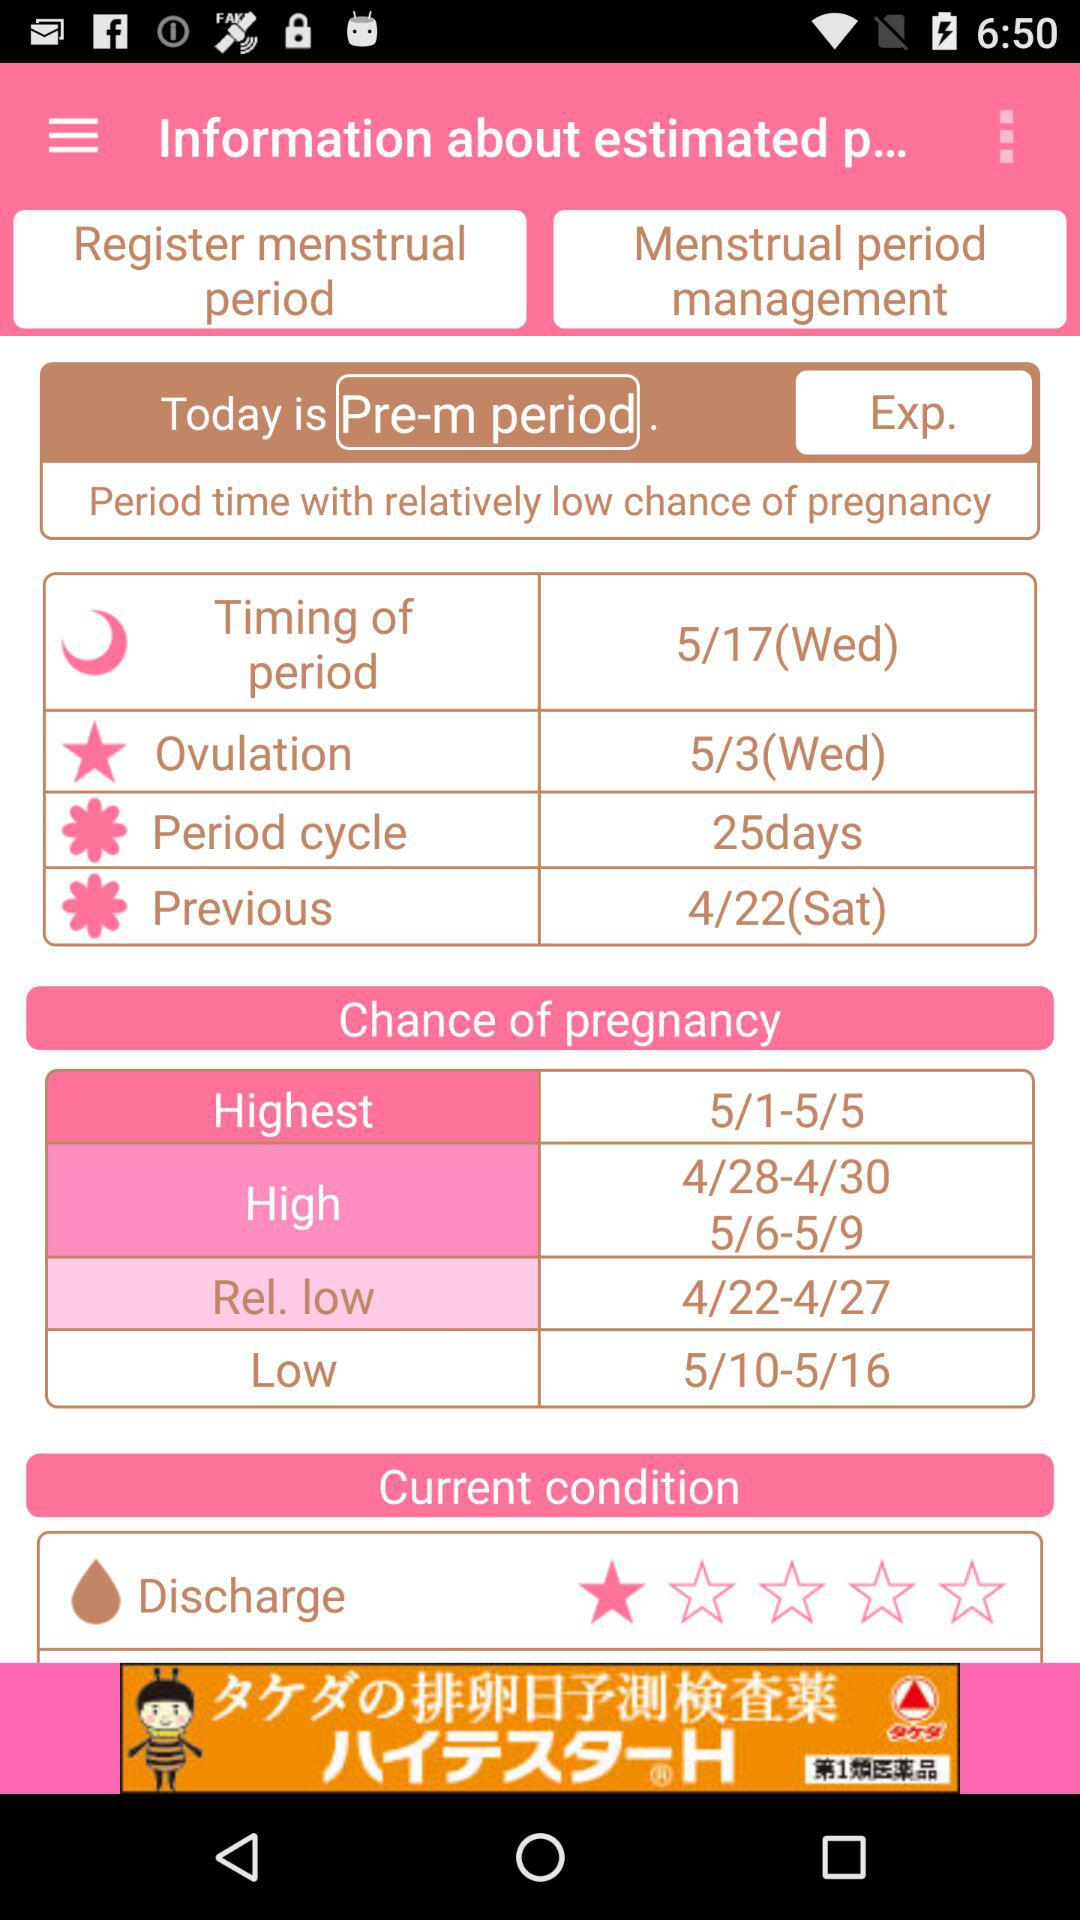What option is selected today? The option is "Pre-m period". 